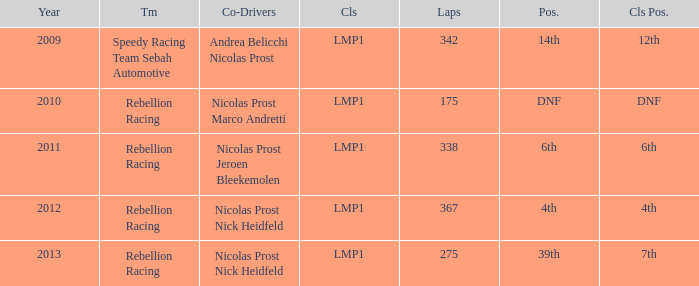For the team ranked 4th, what was their standing within the class? 4th. 